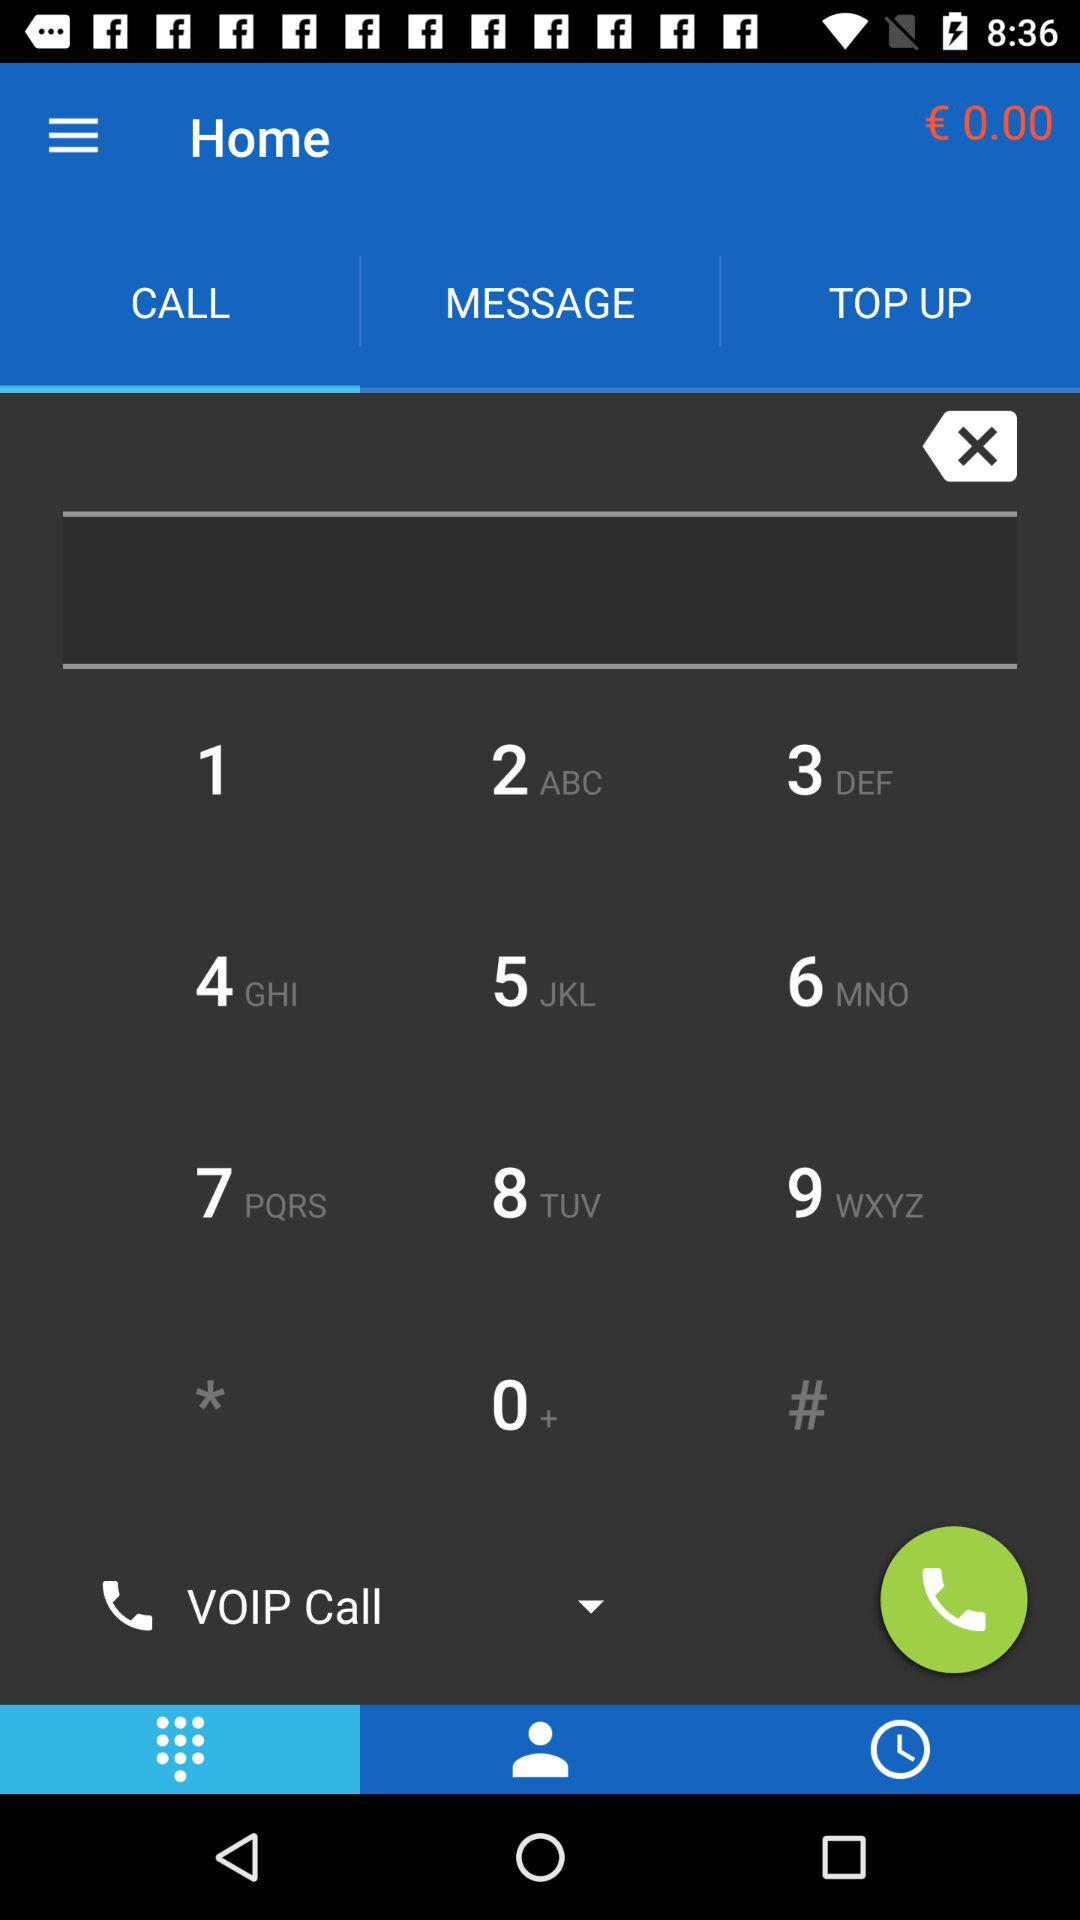What is the selected tab? The selected tabs are "CALL" and "Keypad". 